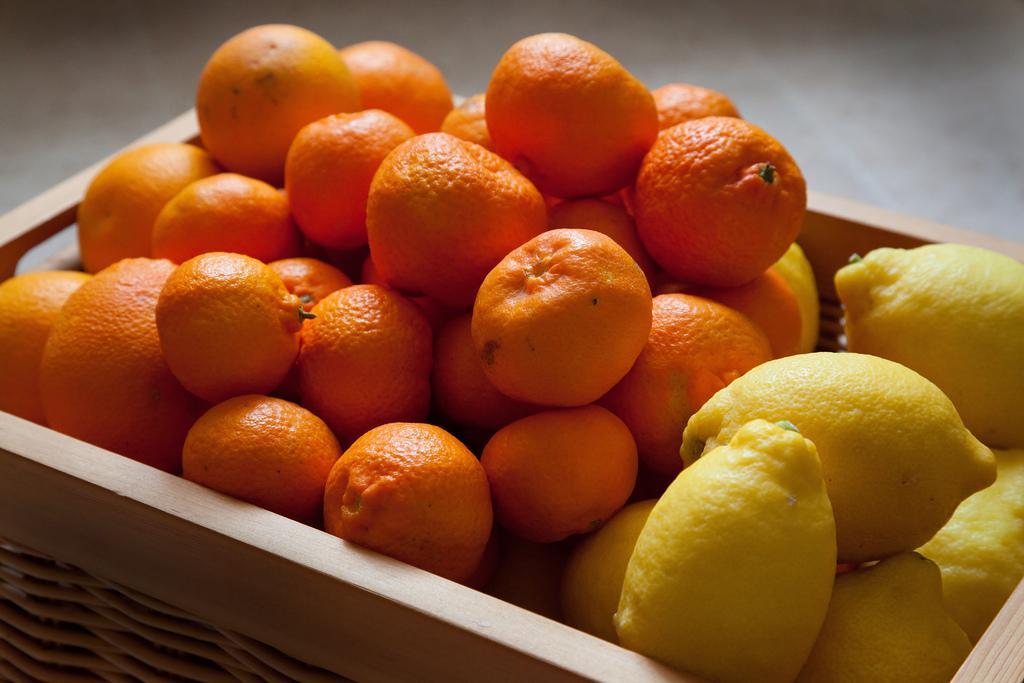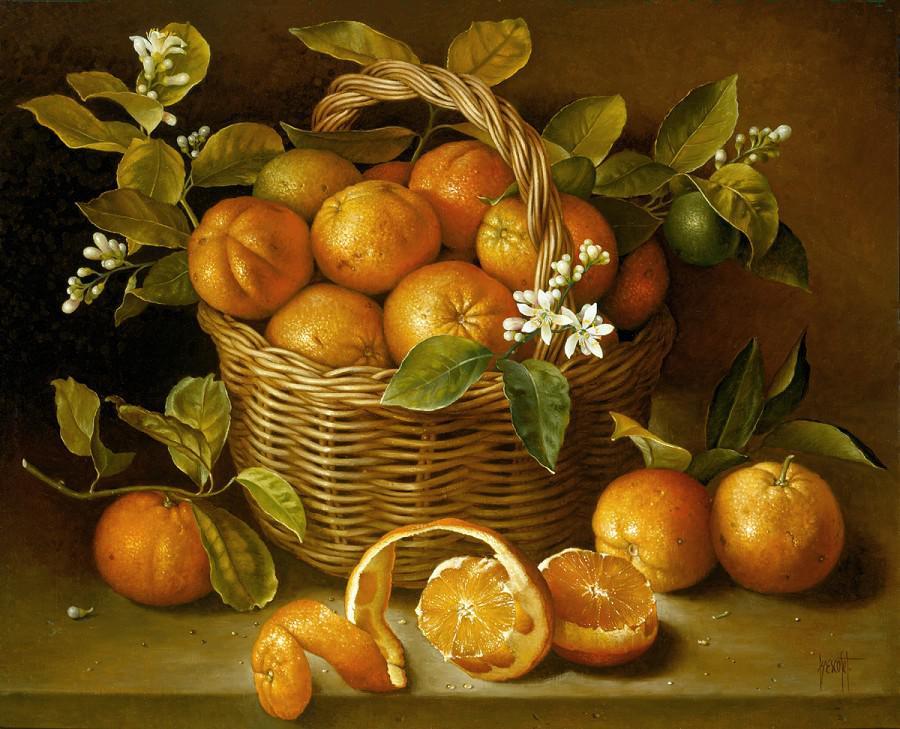The first image is the image on the left, the second image is the image on the right. Evaluate the accuracy of this statement regarding the images: "Each image features a woven basket filled with a variety of at least three kinds of fruit, and at least one image features a basket with a round handle.". Is it true? Answer yes or no. No. 